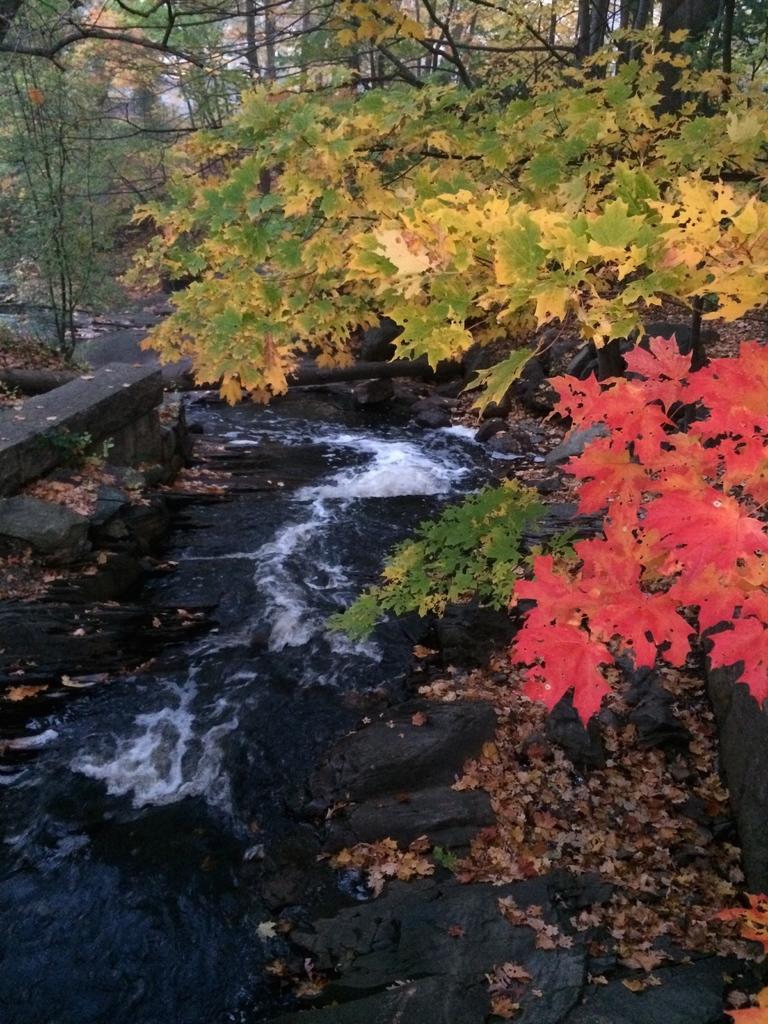In one or two sentences, can you explain what this image depicts? In this image we can see flowing water, shredded leaves, rocks, plants, trees and creepers. 